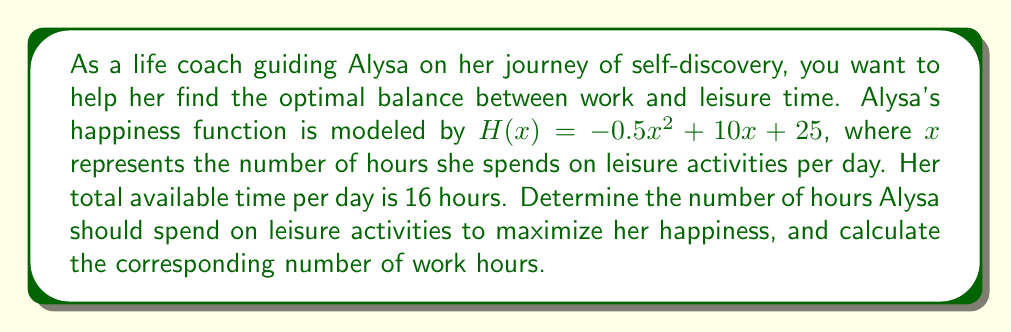Can you solve this math problem? To solve this optimization problem, we'll follow these steps:

1. Identify the objective function and constraints:
   Objective function: $H(x) = -0.5x^2 + 10x + 25$
   Constraint: $0 \leq x \leq 16$ (leisure time can't be negative or exceed total available time)

2. Find the critical points by taking the derivative of $H(x)$ and setting it to zero:
   $$\frac{dH}{dx} = -x + 10$$
   $$-x + 10 = 0$$
   $$x = 10$$

3. Check the endpoints of the interval [0, 16]:
   $H(0) = 25$
   $H(16) = -64$

4. Evaluate $H(x)$ at the critical point $x = 10$:
   $H(10) = -0.5(10)^2 + 10(10) + 25 = -50 + 100 + 25 = 75$

5. Compare the values to find the maximum:
   $H(0) = 25$
   $H(10) = 75$
   $H(16) = -64$

   The maximum occurs at $x = 10$ hours.

6. Calculate the corresponding work hours:
   Total available time = 16 hours
   Work hours = 16 - 10 = 6 hours

Therefore, to maximize her happiness, Alysa should spend 10 hours on leisure activities and 6 hours on work.
Answer: Optimal leisure time: 10 hours
Optimal work time: 6 hours
Maximum happiness value: 75 